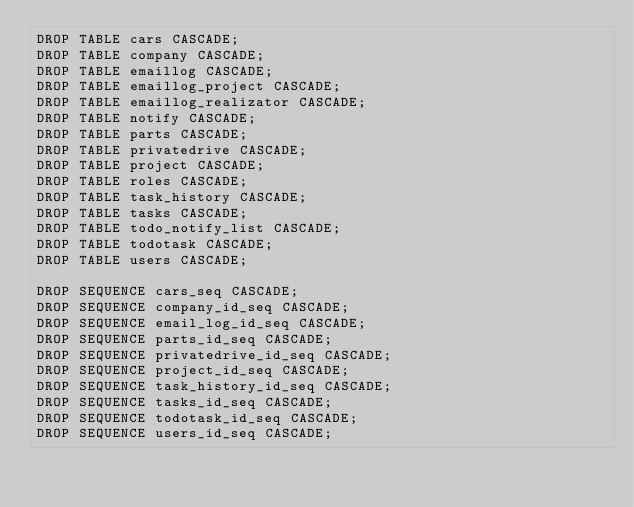<code> <loc_0><loc_0><loc_500><loc_500><_SQL_>DROP TABLE cars CASCADE;
DROP TABLE company CASCADE;
DROP TABLE emaillog CASCADE;
DROP TABLE emaillog_project CASCADE;
DROP TABLE emaillog_realizator CASCADE;
DROP TABLE notify CASCADE;
DROP TABLE parts CASCADE;
DROP TABLE privatedrive CASCADE;
DROP TABLE project CASCADE;
DROP TABLE roles CASCADE;
DROP TABLE task_history CASCADE;
DROP TABLE tasks CASCADE;
DROP TABLE todo_notify_list CASCADE;
DROP TABLE todotask CASCADE;
DROP TABLE users CASCADE;

DROP SEQUENCE cars_seq CASCADE;
DROP SEQUENCE company_id_seq CASCADE;
DROP SEQUENCE email_log_id_seq CASCADE;
DROP SEQUENCE parts_id_seq CASCADE;
DROP SEQUENCE privatedrive_id_seq CASCADE;
DROP SEQUENCE project_id_seq CASCADE;
DROP SEQUENCE task_history_id_seq CASCADE;
DROP SEQUENCE tasks_id_seq CASCADE;
DROP SEQUENCE todotask_id_seq CASCADE;
DROP SEQUENCE users_id_seq CASCADE;
</code> 